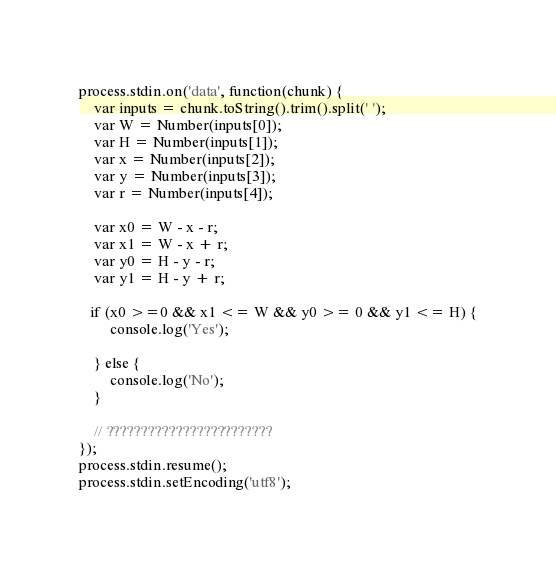Convert code to text. <code><loc_0><loc_0><loc_500><loc_500><_JavaScript_>process.stdin.on('data', function(chunk) {
    var inputs = chunk.toString().trim().split(' ');
    var W = Number(inputs[0]);
    var H = Number(inputs[1]);
    var x = Number(inputs[2]);
    var y = Number(inputs[3]);
    var r = Number(inputs[4]);

    var x0 = W - x - r;
    var x1 = W - x + r;
    var y0 = H - y - r;
    var y1 = H - y + r;

   if (x0 >=0 && x1 <= W && y0 >= 0 && y1 <= H) {
        console.log('Yes');

    } else {
        console.log('No');
    }

    // ????????????????????????
});
process.stdin.resume();
process.stdin.setEncoding('utf8');</code> 